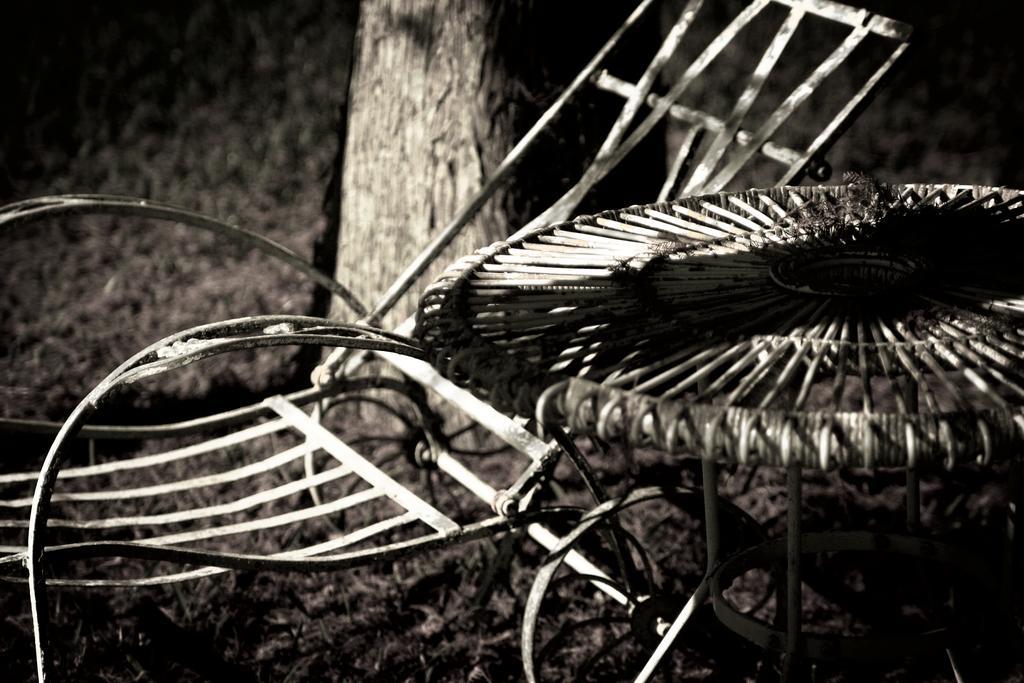Can you describe this image briefly? This is a black and white pic. We can see a chair, table, tree and grass on the ground. 